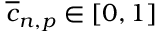<formula> <loc_0><loc_0><loc_500><loc_500>\overline { c } _ { n , p } \in [ 0 , 1 ]</formula> 